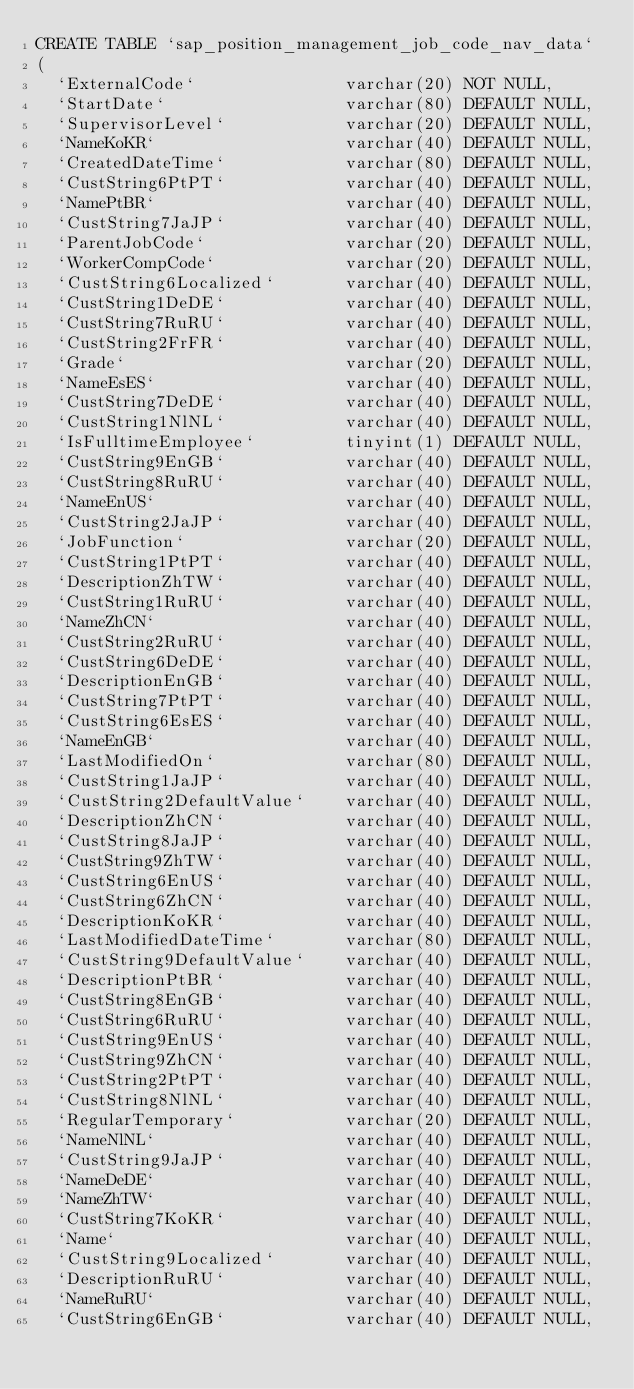Convert code to text. <code><loc_0><loc_0><loc_500><loc_500><_SQL_>CREATE TABLE `sap_position_management_job_code_nav_data`
(
  `ExternalCode`               varchar(20) NOT NULL,
  `StartDate`                  varchar(80) DEFAULT NULL,
  `SupervisorLevel`            varchar(20) DEFAULT NULL,
  `NameKoKR`                   varchar(40) DEFAULT NULL,
  `CreatedDateTime`            varchar(80) DEFAULT NULL,
  `CustString6PtPT`            varchar(40) DEFAULT NULL,
  `NamePtBR`                   varchar(40) DEFAULT NULL,
  `CustString7JaJP`            varchar(40) DEFAULT NULL,
  `ParentJobCode`              varchar(20) DEFAULT NULL,
  `WorkerCompCode`             varchar(20) DEFAULT NULL,
  `CustString6Localized`       varchar(40) DEFAULT NULL,
  `CustString1DeDE`            varchar(40) DEFAULT NULL,
  `CustString7RuRU`            varchar(40) DEFAULT NULL,
  `CustString2FrFR`            varchar(40) DEFAULT NULL,
  `Grade`                      varchar(20) DEFAULT NULL,
  `NameEsES`                   varchar(40) DEFAULT NULL,
  `CustString7DeDE`            varchar(40) DEFAULT NULL,
  `CustString1NlNL`            varchar(40) DEFAULT NULL,
  `IsFulltimeEmployee`         tinyint(1) DEFAULT NULL,
  `CustString9EnGB`            varchar(40) DEFAULT NULL,
  `CustString8RuRU`            varchar(40) DEFAULT NULL,
  `NameEnUS`                   varchar(40) DEFAULT NULL,
  `CustString2JaJP`            varchar(40) DEFAULT NULL,
  `JobFunction`                varchar(20) DEFAULT NULL,
  `CustString1PtPT`            varchar(40) DEFAULT NULL,
  `DescriptionZhTW`            varchar(40) DEFAULT NULL,
  `CustString1RuRU`            varchar(40) DEFAULT NULL,
  `NameZhCN`                   varchar(40) DEFAULT NULL,
  `CustString2RuRU`            varchar(40) DEFAULT NULL,
  `CustString6DeDE`            varchar(40) DEFAULT NULL,
  `DescriptionEnGB`            varchar(40) DEFAULT NULL,
  `CustString7PtPT`            varchar(40) DEFAULT NULL,
  `CustString6EsES`            varchar(40) DEFAULT NULL,
  `NameEnGB`                   varchar(40) DEFAULT NULL,
  `LastModifiedOn`             varchar(80) DEFAULT NULL,
  `CustString1JaJP`            varchar(40) DEFAULT NULL,
  `CustString2DefaultValue`    varchar(40) DEFAULT NULL,
  `DescriptionZhCN`            varchar(40) DEFAULT NULL,
  `CustString8JaJP`            varchar(40) DEFAULT NULL,
  `CustString9ZhTW`            varchar(40) DEFAULT NULL,
  `CustString6EnUS`            varchar(40) DEFAULT NULL,
  `CustString6ZhCN`            varchar(40) DEFAULT NULL,
  `DescriptionKoKR`            varchar(40) DEFAULT NULL,
  `LastModifiedDateTime`       varchar(80) DEFAULT NULL,
  `CustString9DefaultValue`    varchar(40) DEFAULT NULL,
  `DescriptionPtBR`            varchar(40) DEFAULT NULL,
  `CustString8EnGB`            varchar(40) DEFAULT NULL,
  `CustString6RuRU`            varchar(40) DEFAULT NULL,
  `CustString9EnUS`            varchar(40) DEFAULT NULL,
  `CustString9ZhCN`            varchar(40) DEFAULT NULL,
  `CustString2PtPT`            varchar(40) DEFAULT NULL,
  `CustString8NlNL`            varchar(40) DEFAULT NULL,
  `RegularTemporary`           varchar(20) DEFAULT NULL,
  `NameNlNL`                   varchar(40) DEFAULT NULL,
  `CustString9JaJP`            varchar(40) DEFAULT NULL,
  `NameDeDE`                   varchar(40) DEFAULT NULL,
  `NameZhTW`                   varchar(40) DEFAULT NULL,
  `CustString7KoKR`            varchar(40) DEFAULT NULL,
  `Name`                       varchar(40) DEFAULT NULL,
  `CustString9Localized`       varchar(40) DEFAULT NULL,
  `DescriptionRuRU`            varchar(40) DEFAULT NULL,
  `NameRuRU`                   varchar(40) DEFAULT NULL,
  `CustString6EnGB`            varchar(40) DEFAULT NULL,</code> 